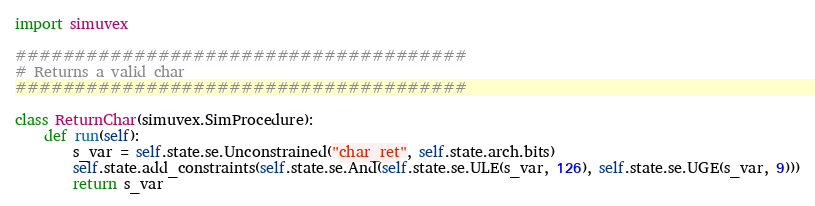<code> <loc_0><loc_0><loc_500><loc_500><_Python_>import simuvex

######################################
# Returns a valid char
######################################

class ReturnChar(simuvex.SimProcedure):
    def run(self):
        s_var = self.state.se.Unconstrained("char_ret", self.state.arch.bits)
        self.state.add_constraints(self.state.se.And(self.state.se.ULE(s_var, 126), self.state.se.UGE(s_var, 9)))
        return s_var
</code> 